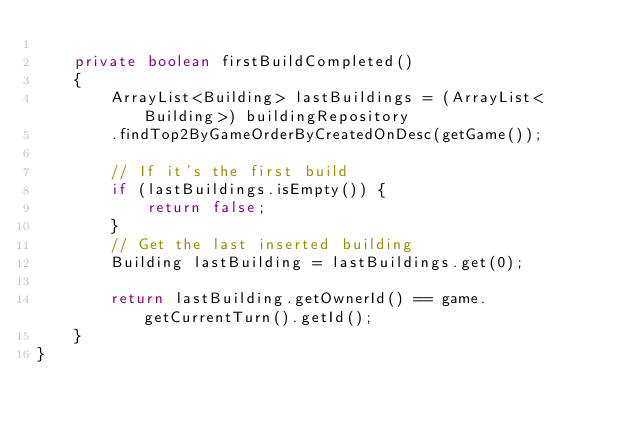<code> <loc_0><loc_0><loc_500><loc_500><_Java_>
    private boolean firstBuildCompleted()
    {
        ArrayList<Building> lastBuildings = (ArrayList<Building>) buildingRepository
        .findTop2ByGameOrderByCreatedOnDesc(getGame());

        // If it's the first build
        if (lastBuildings.isEmpty()) {
            return false;
        }
        // Get the last inserted building
        Building lastBuilding = lastBuildings.get(0);

        return lastBuilding.getOwnerId() == game.getCurrentTurn().getId();
    }
}
</code> 